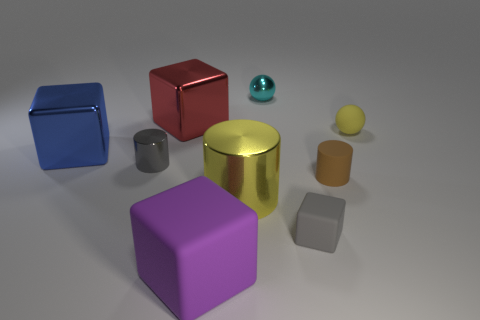Is the material of the tiny ball that is behind the tiny yellow matte sphere the same as the cylinder to the left of the big purple rubber block?
Provide a short and direct response. Yes. The large metallic thing that is to the right of the big shiny block that is behind the small yellow sphere is what shape?
Your response must be concise. Cylinder. Is there any other thing that is the same color as the matte sphere?
Ensure brevity in your answer.  Yes. There is a big metal cube left of the cylinder that is on the left side of the big purple cube; is there a large red metal block right of it?
Keep it short and to the point. Yes. Do the small shiny thing that is in front of the large blue thing and the tiny object in front of the large yellow metallic object have the same color?
Your answer should be compact. Yes. There is a yellow object that is the same size as the brown cylinder; what is it made of?
Provide a succinct answer. Rubber. How big is the cyan object behind the big shiny thing that is on the left side of the small cylinder behind the rubber cylinder?
Make the answer very short. Small. What number of other things are made of the same material as the blue thing?
Offer a very short reply. 4. What is the size of the yellow object behind the large blue metallic block?
Your response must be concise. Small. How many matte objects are both in front of the large yellow metal object and behind the blue block?
Ensure brevity in your answer.  0. 